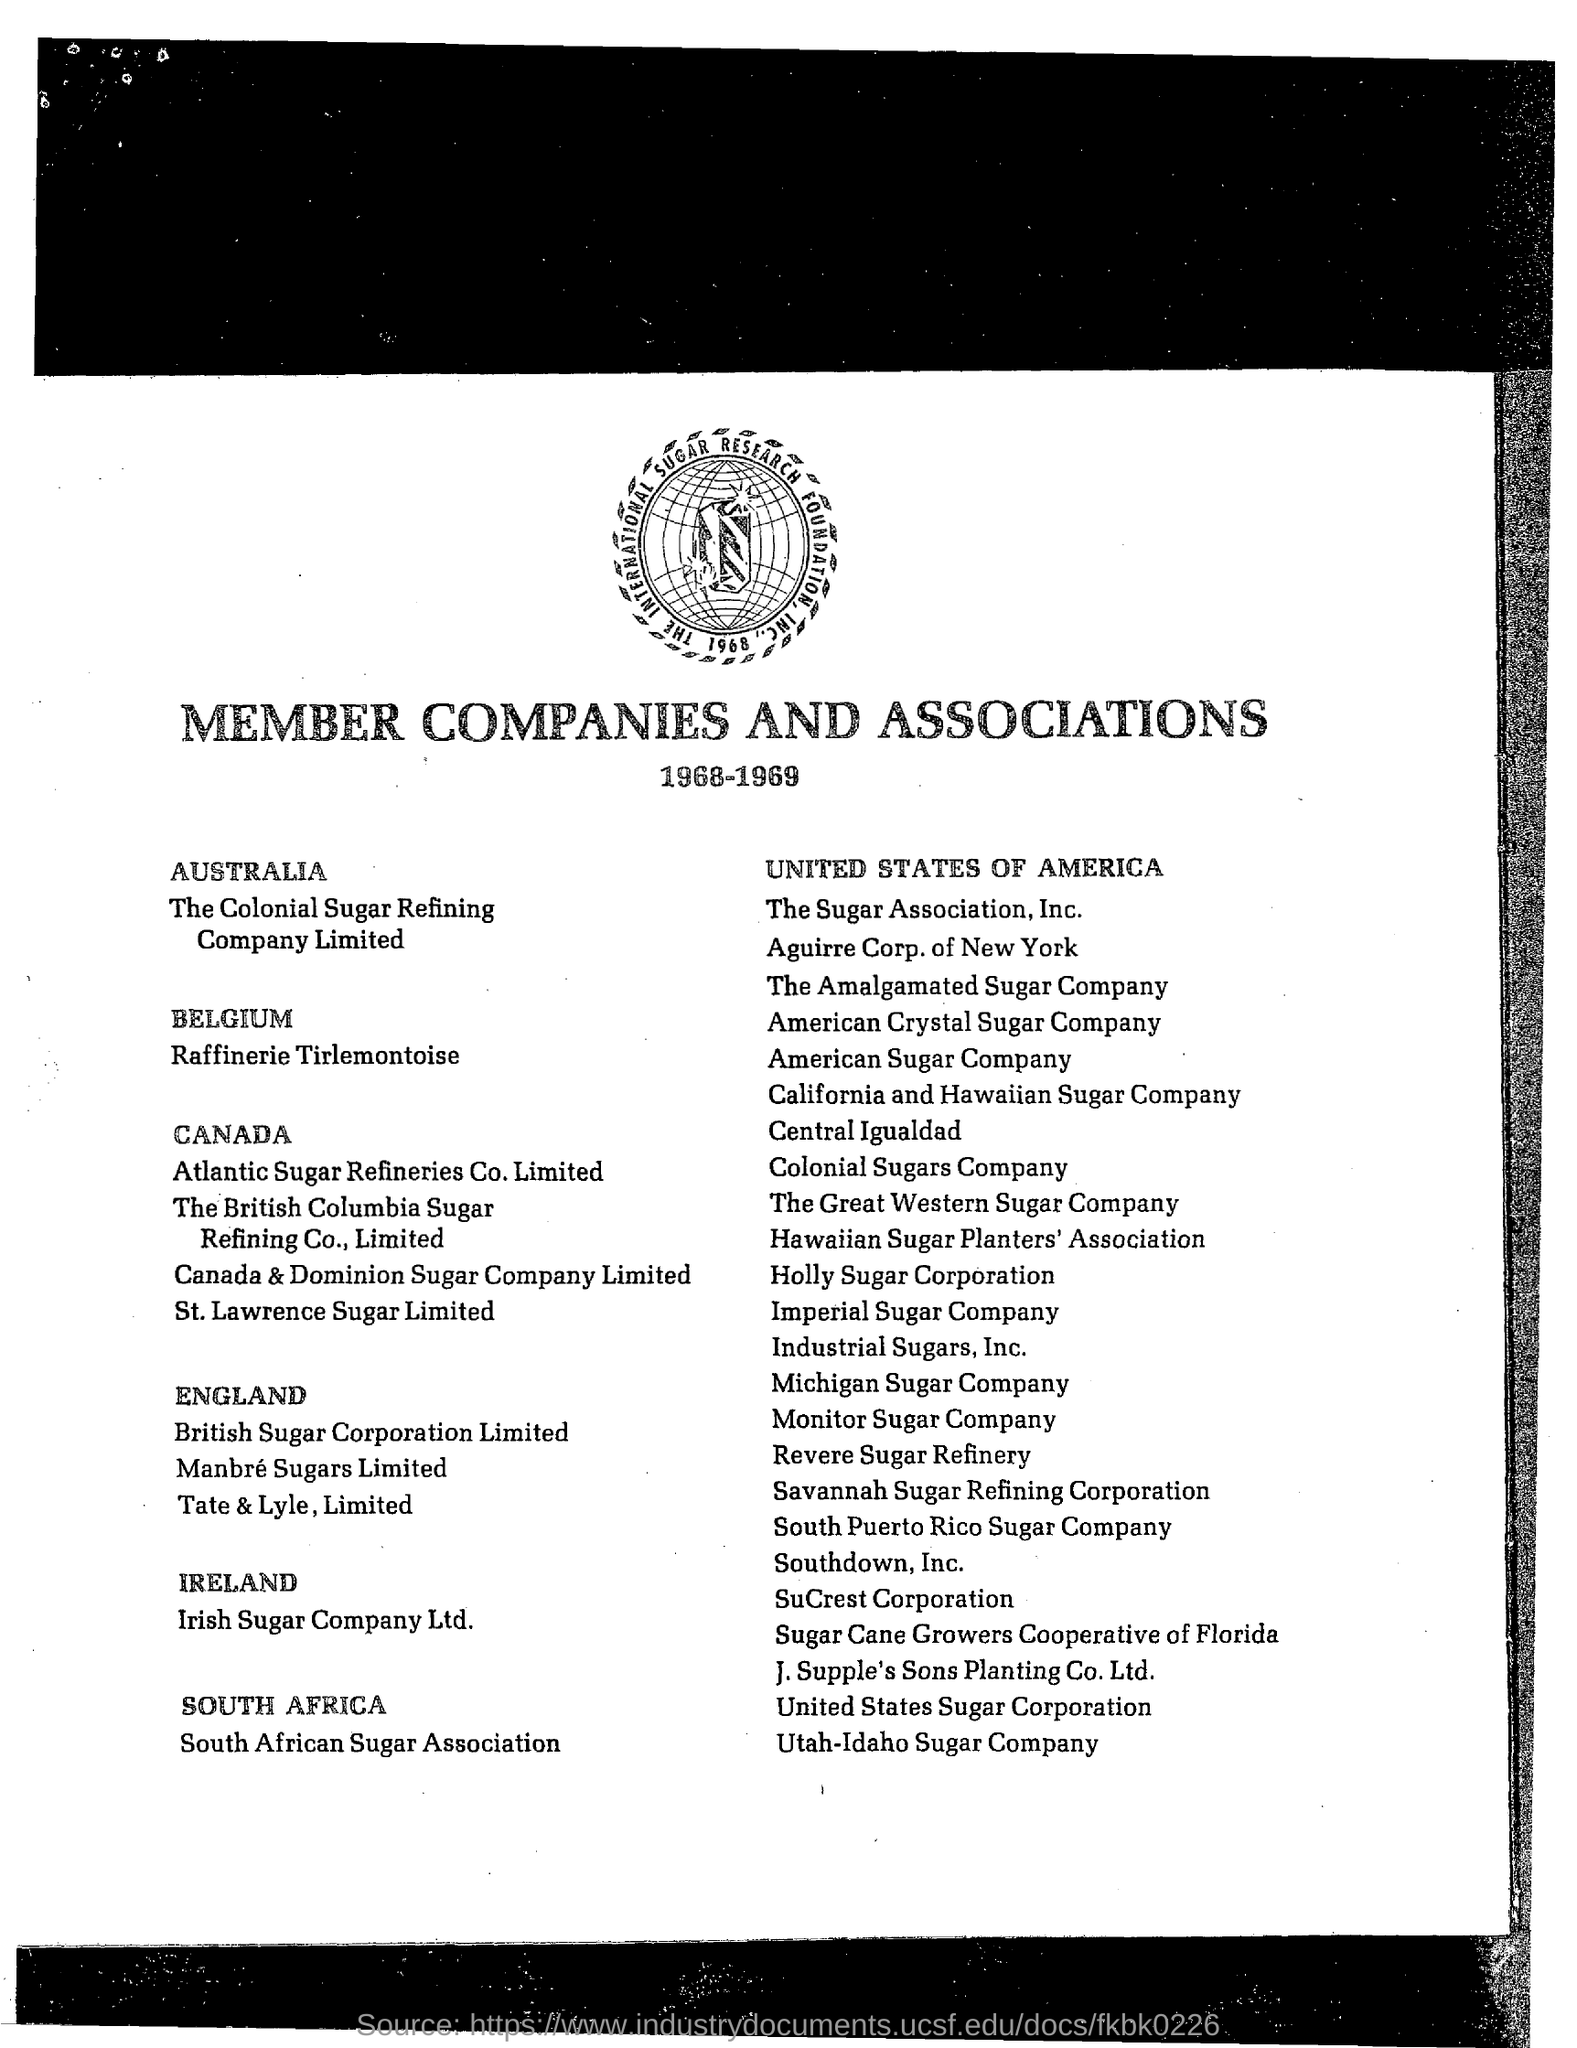Which association is mentioned?
Offer a terse response. MEMBER COMPANIES AND ASSOCIATIONS. Which is the member company in AUSTRALIA?
Give a very brief answer. The Colonial Sugar Refining Company Limited. Where is the Utah-Idaho Sugar Company located?
Ensure brevity in your answer.  UNITED STATES OF AMERICA. Which company is from IRELAND?
Ensure brevity in your answer.  Irish Sugar Company Ltd. 